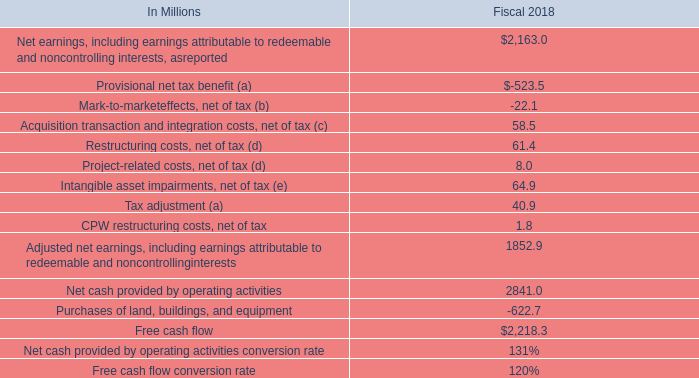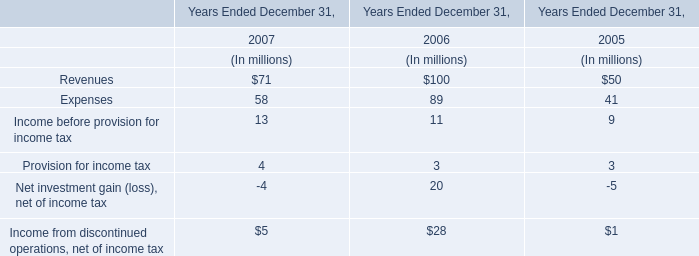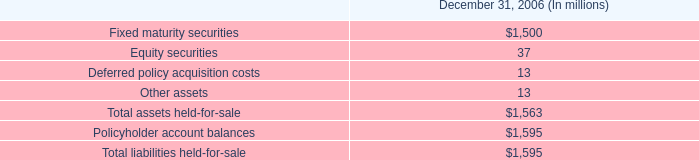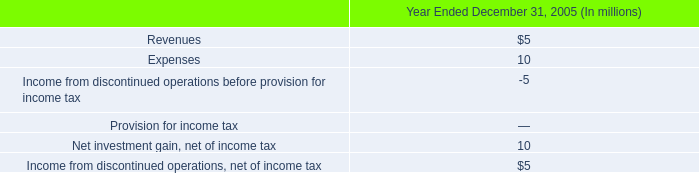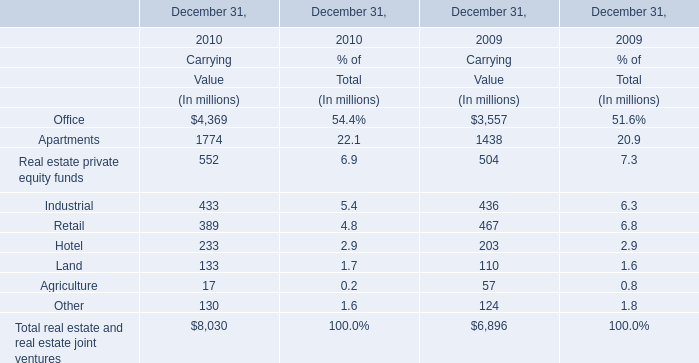In the year with the most Office for CarryingValue, what is the growth rate of Retail for CarryingValue ? 
Computations: ((389 - 467) / 389)
Answer: -0.20051. 